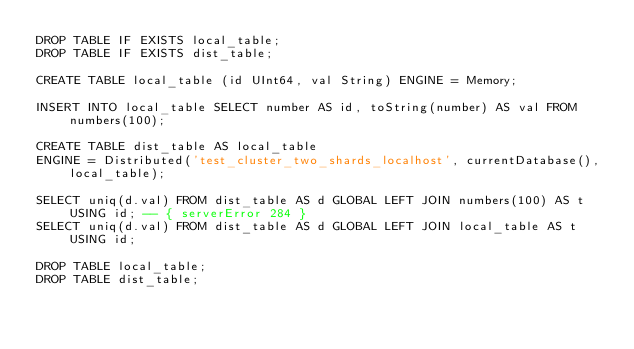<code> <loc_0><loc_0><loc_500><loc_500><_SQL_>DROP TABLE IF EXISTS local_table;
DROP TABLE IF EXISTS dist_table;

CREATE TABLE local_table (id UInt64, val String) ENGINE = Memory;

INSERT INTO local_table SELECT number AS id, toString(number) AS val FROM numbers(100);

CREATE TABLE dist_table AS local_table
ENGINE = Distributed('test_cluster_two_shards_localhost', currentDatabase(), local_table);

SELECT uniq(d.val) FROM dist_table AS d GLOBAL LEFT JOIN numbers(100) AS t USING id; -- { serverError 284 }
SELECT uniq(d.val) FROM dist_table AS d GLOBAL LEFT JOIN local_table AS t USING id;

DROP TABLE local_table;
DROP TABLE dist_table;
</code> 